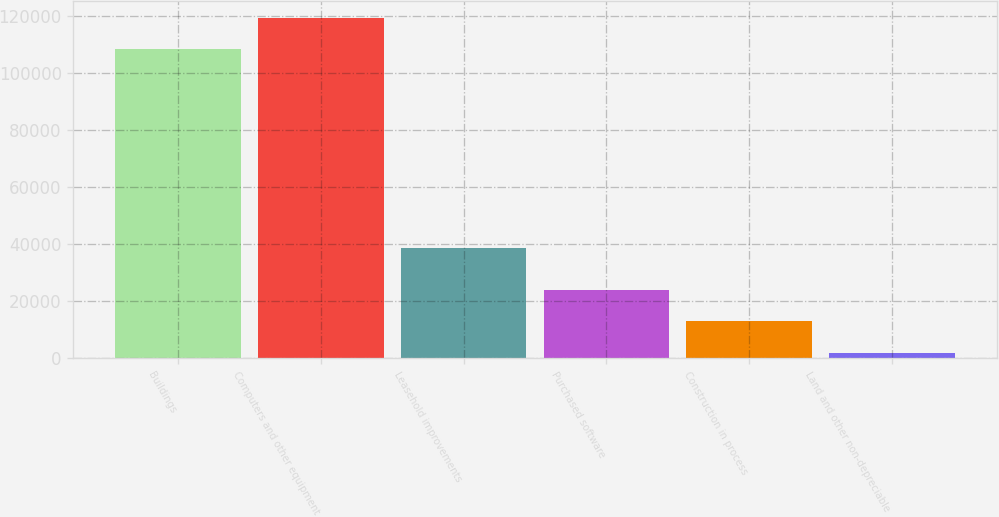Convert chart to OTSL. <chart><loc_0><loc_0><loc_500><loc_500><bar_chart><fcel>Buildings<fcel>Computers and other equipment<fcel>Leasehold improvements<fcel>Purchased software<fcel>Construction in process<fcel>Land and other non-depreciable<nl><fcel>108265<fcel>119297<fcel>38771<fcel>23950.2<fcel>12918.6<fcel>1887<nl></chart> 